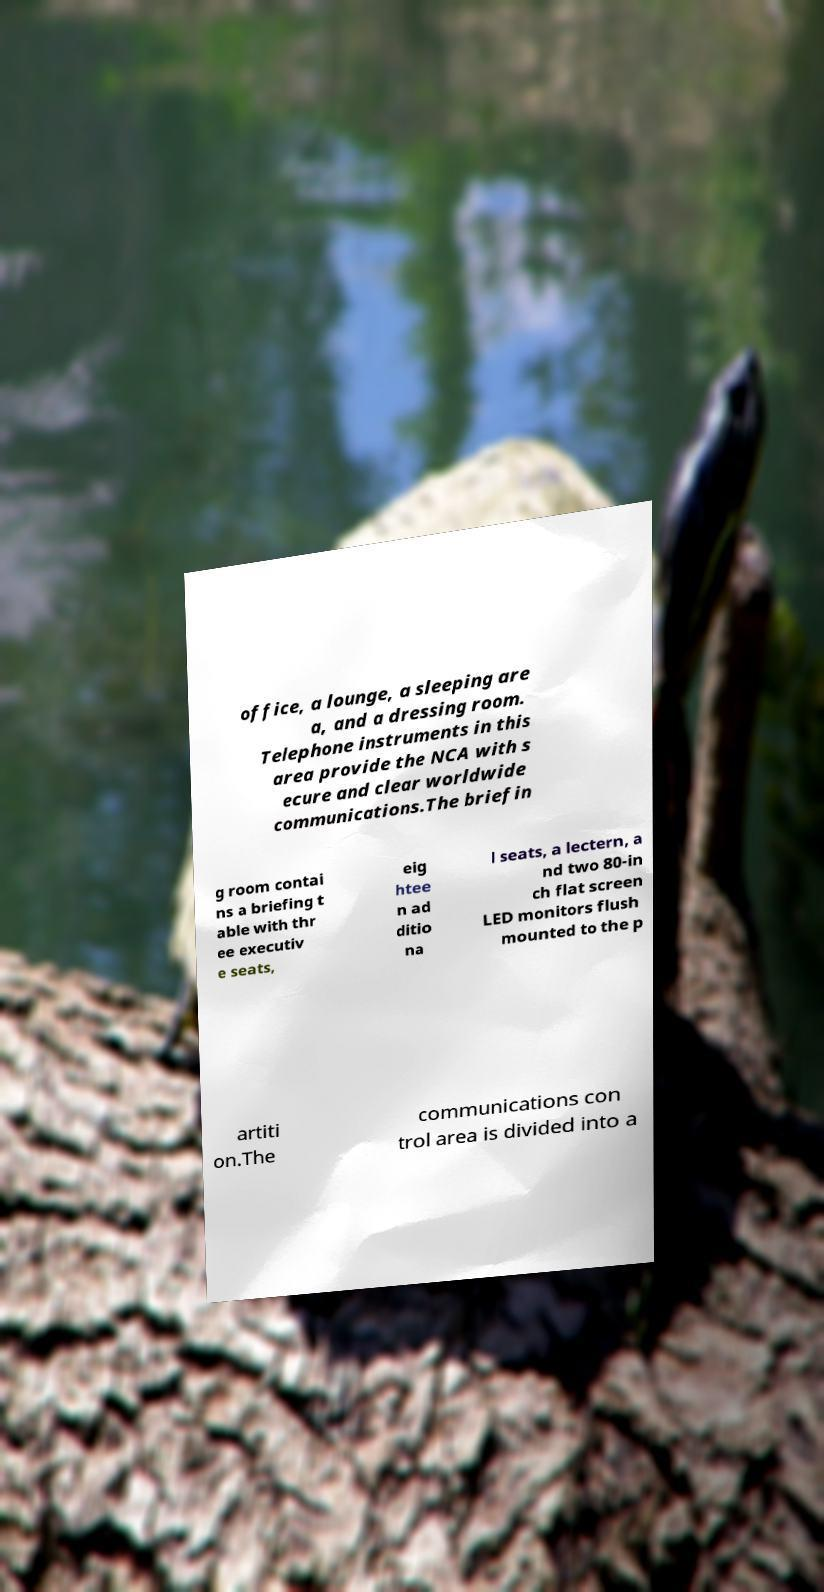Please identify and transcribe the text found in this image. office, a lounge, a sleeping are a, and a dressing room. Telephone instruments in this area provide the NCA with s ecure and clear worldwide communications.The briefin g room contai ns a briefing t able with thr ee executiv e seats, eig htee n ad ditio na l seats, a lectern, a nd two 80-in ch flat screen LED monitors flush mounted to the p artiti on.The communications con trol area is divided into a 